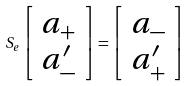Convert formula to latex. <formula><loc_0><loc_0><loc_500><loc_500>S _ { e } \left [ \begin{array} { c } a _ { + } \\ a _ { - } ^ { \prime } \end{array} \right ] = \left [ \begin{array} { c } a _ { - } \\ a _ { + } ^ { \prime } \end{array} \right ]</formula> 